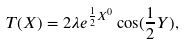<formula> <loc_0><loc_0><loc_500><loc_500>T ( X ) = 2 \lambda e ^ { \frac { 1 } { 2 } X ^ { 0 } } \cos ( \frac { 1 } { 2 } Y ) ,</formula> 